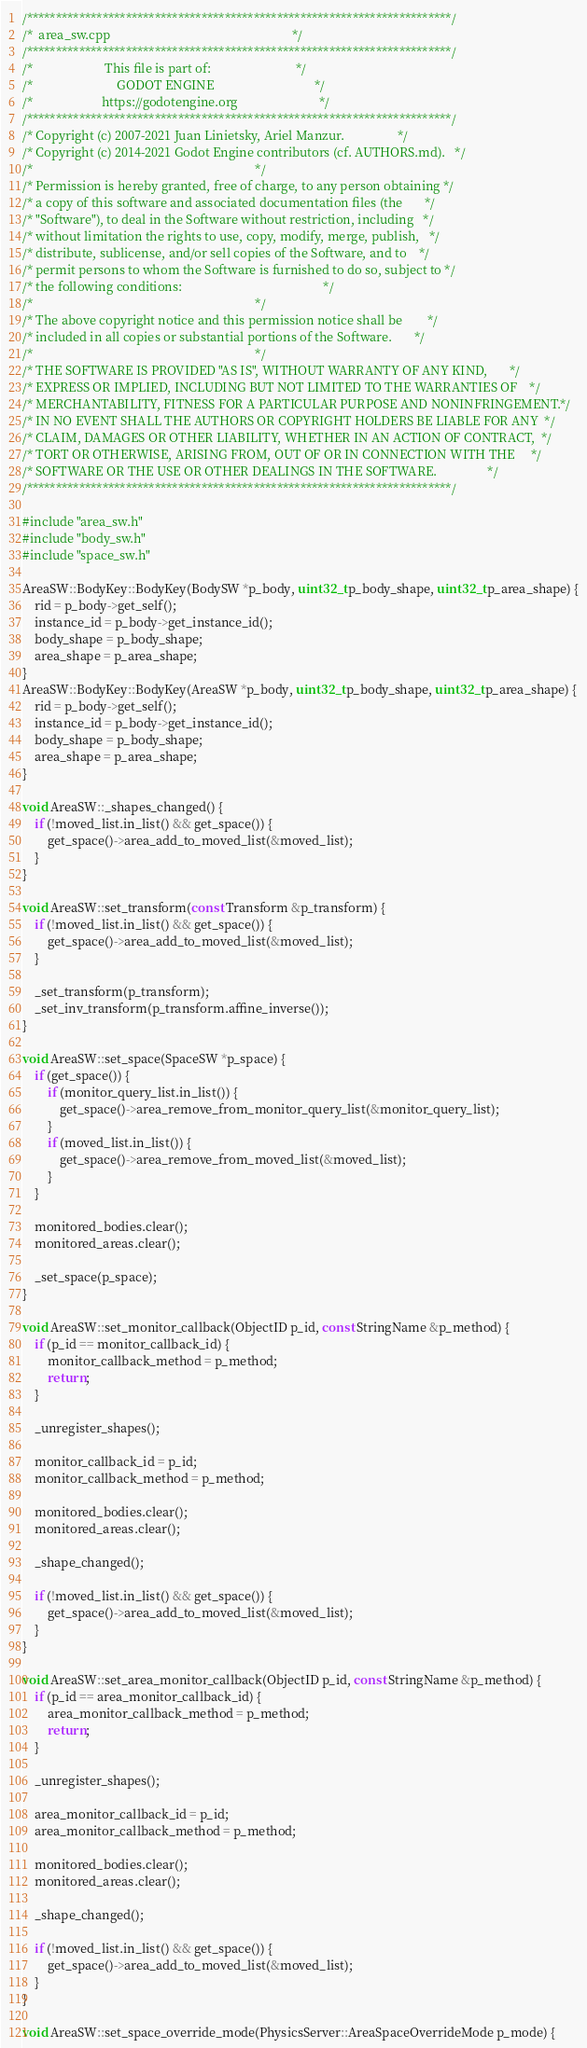Convert code to text. <code><loc_0><loc_0><loc_500><loc_500><_C++_>/*************************************************************************/
/*  area_sw.cpp                                                          */
/*************************************************************************/
/*                       This file is part of:                           */
/*                           GODOT ENGINE                                */
/*                      https://godotengine.org                          */
/*************************************************************************/
/* Copyright (c) 2007-2021 Juan Linietsky, Ariel Manzur.                 */
/* Copyright (c) 2014-2021 Godot Engine contributors (cf. AUTHORS.md).   */
/*                                                                       */
/* Permission is hereby granted, free of charge, to any person obtaining */
/* a copy of this software and associated documentation files (the       */
/* "Software"), to deal in the Software without restriction, including   */
/* without limitation the rights to use, copy, modify, merge, publish,   */
/* distribute, sublicense, and/or sell copies of the Software, and to    */
/* permit persons to whom the Software is furnished to do so, subject to */
/* the following conditions:                                             */
/*                                                                       */
/* The above copyright notice and this permission notice shall be        */
/* included in all copies or substantial portions of the Software.       */
/*                                                                       */
/* THE SOFTWARE IS PROVIDED "AS IS", WITHOUT WARRANTY OF ANY KIND,       */
/* EXPRESS OR IMPLIED, INCLUDING BUT NOT LIMITED TO THE WARRANTIES OF    */
/* MERCHANTABILITY, FITNESS FOR A PARTICULAR PURPOSE AND NONINFRINGEMENT.*/
/* IN NO EVENT SHALL THE AUTHORS OR COPYRIGHT HOLDERS BE LIABLE FOR ANY  */
/* CLAIM, DAMAGES OR OTHER LIABILITY, WHETHER IN AN ACTION OF CONTRACT,  */
/* TORT OR OTHERWISE, ARISING FROM, OUT OF OR IN CONNECTION WITH THE     */
/* SOFTWARE OR THE USE OR OTHER DEALINGS IN THE SOFTWARE.                */
/*************************************************************************/

#include "area_sw.h"
#include "body_sw.h"
#include "space_sw.h"

AreaSW::BodyKey::BodyKey(BodySW *p_body, uint32_t p_body_shape, uint32_t p_area_shape) {
	rid = p_body->get_self();
	instance_id = p_body->get_instance_id();
	body_shape = p_body_shape;
	area_shape = p_area_shape;
}
AreaSW::BodyKey::BodyKey(AreaSW *p_body, uint32_t p_body_shape, uint32_t p_area_shape) {
	rid = p_body->get_self();
	instance_id = p_body->get_instance_id();
	body_shape = p_body_shape;
	area_shape = p_area_shape;
}

void AreaSW::_shapes_changed() {
	if (!moved_list.in_list() && get_space()) {
		get_space()->area_add_to_moved_list(&moved_list);
	}
}

void AreaSW::set_transform(const Transform &p_transform) {
	if (!moved_list.in_list() && get_space()) {
		get_space()->area_add_to_moved_list(&moved_list);
	}

	_set_transform(p_transform);
	_set_inv_transform(p_transform.affine_inverse());
}

void AreaSW::set_space(SpaceSW *p_space) {
	if (get_space()) {
		if (monitor_query_list.in_list()) {
			get_space()->area_remove_from_monitor_query_list(&monitor_query_list);
		}
		if (moved_list.in_list()) {
			get_space()->area_remove_from_moved_list(&moved_list);
		}
	}

	monitored_bodies.clear();
	monitored_areas.clear();

	_set_space(p_space);
}

void AreaSW::set_monitor_callback(ObjectID p_id, const StringName &p_method) {
	if (p_id == monitor_callback_id) {
		monitor_callback_method = p_method;
		return;
	}

	_unregister_shapes();

	monitor_callback_id = p_id;
	monitor_callback_method = p_method;

	monitored_bodies.clear();
	monitored_areas.clear();

	_shape_changed();

	if (!moved_list.in_list() && get_space()) {
		get_space()->area_add_to_moved_list(&moved_list);
	}
}

void AreaSW::set_area_monitor_callback(ObjectID p_id, const StringName &p_method) {
	if (p_id == area_monitor_callback_id) {
		area_monitor_callback_method = p_method;
		return;
	}

	_unregister_shapes();

	area_monitor_callback_id = p_id;
	area_monitor_callback_method = p_method;

	monitored_bodies.clear();
	monitored_areas.clear();

	_shape_changed();

	if (!moved_list.in_list() && get_space()) {
		get_space()->area_add_to_moved_list(&moved_list);
	}
}

void AreaSW::set_space_override_mode(PhysicsServer::AreaSpaceOverrideMode p_mode) {</code> 